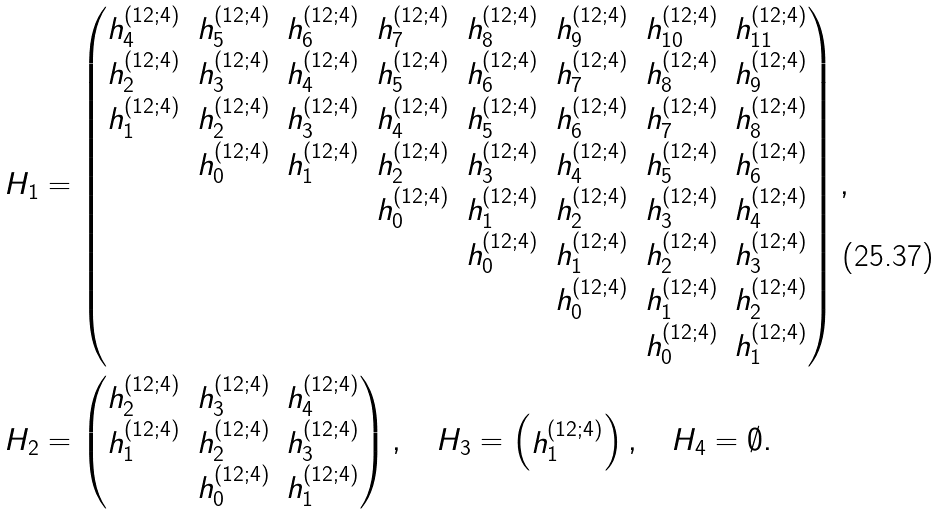<formula> <loc_0><loc_0><loc_500><loc_500>H _ { 1 } & = \begin{pmatrix} h _ { 4 } ^ { ( 1 2 ; 4 ) } & h _ { 5 } ^ { ( 1 2 ; 4 ) } & h _ { 6 } ^ { ( 1 2 ; 4 ) } & h _ { 7 } ^ { ( 1 2 ; 4 ) } & h _ { 8 } ^ { ( 1 2 ; 4 ) } & h _ { 9 } ^ { ( 1 2 ; 4 ) } & h _ { 1 0 } ^ { ( 1 2 ; 4 ) } & h _ { 1 1 } ^ { ( 1 2 ; 4 ) } \\ h _ { 2 } ^ { ( 1 2 ; 4 ) } & h _ { 3 } ^ { ( 1 2 ; 4 ) } & h _ { 4 } ^ { ( 1 2 ; 4 ) } & h _ { 5 } ^ { ( 1 2 ; 4 ) } & h _ { 6 } ^ { ( 1 2 ; 4 ) } & h _ { 7 } ^ { ( 1 2 ; 4 ) } & h _ { 8 } ^ { ( 1 2 ; 4 ) } & h _ { 9 } ^ { ( 1 2 ; 4 ) } \\ h _ { 1 } ^ { ( 1 2 ; 4 ) } & h _ { 2 } ^ { ( 1 2 ; 4 ) } & h _ { 3 } ^ { ( 1 2 ; 4 ) } & h _ { 4 } ^ { ( 1 2 ; 4 ) } & h _ { 5 } ^ { ( 1 2 ; 4 ) } & h _ { 6 } ^ { ( 1 2 ; 4 ) } & h _ { 7 } ^ { ( 1 2 ; 4 ) } & h _ { 8 } ^ { ( 1 2 ; 4 ) } \\ & h _ { 0 } ^ { ( 1 2 ; 4 ) } & h _ { 1 } ^ { ( 1 2 ; 4 ) } & h _ { 2 } ^ { ( 1 2 ; 4 ) } & h _ { 3 } ^ { ( 1 2 ; 4 ) } & h _ { 4 } ^ { ( 1 2 ; 4 ) } & h _ { 5 } ^ { ( 1 2 ; 4 ) } & h _ { 6 } ^ { ( 1 2 ; 4 ) } \\ & & & h _ { 0 } ^ { ( 1 2 ; 4 ) } & h _ { 1 } ^ { ( 1 2 ; 4 ) } & h _ { 2 } ^ { ( 1 2 ; 4 ) } & h _ { 3 } ^ { ( 1 2 ; 4 ) } & h _ { 4 } ^ { ( 1 2 ; 4 ) } \\ & & & & h _ { 0 } ^ { ( 1 2 ; 4 ) } & h _ { 1 } ^ { ( 1 2 ; 4 ) } & h _ { 2 } ^ { ( 1 2 ; 4 ) } & h _ { 3 } ^ { ( 1 2 ; 4 ) } \\ & & & & & h _ { 0 } ^ { ( 1 2 ; 4 ) } & h _ { 1 } ^ { ( 1 2 ; 4 ) } & h _ { 2 } ^ { ( 1 2 ; 4 ) } \\ & & & & & & h _ { 0 } ^ { ( 1 2 ; 4 ) } & h _ { 1 } ^ { ( 1 2 ; 4 ) } \end{pmatrix} , \\ H _ { 2 } & = \begin{pmatrix} h _ { 2 } ^ { ( 1 2 ; 4 ) } & h _ { 3 } ^ { ( 1 2 ; 4 ) } & h _ { 4 } ^ { ( 1 2 ; 4 ) } \\ h _ { 1 } ^ { ( 1 2 ; 4 ) } & h _ { 2 } ^ { ( 1 2 ; 4 ) } & h _ { 3 } ^ { ( 1 2 ; 4 ) } \\ & h _ { 0 } ^ { ( 1 2 ; 4 ) } & h _ { 1 } ^ { ( 1 2 ; 4 ) } \end{pmatrix} , \quad H _ { 3 } = \begin{pmatrix} h _ { 1 } ^ { ( 1 2 ; 4 ) } \end{pmatrix} , \quad H _ { 4 } = \emptyset .</formula> 